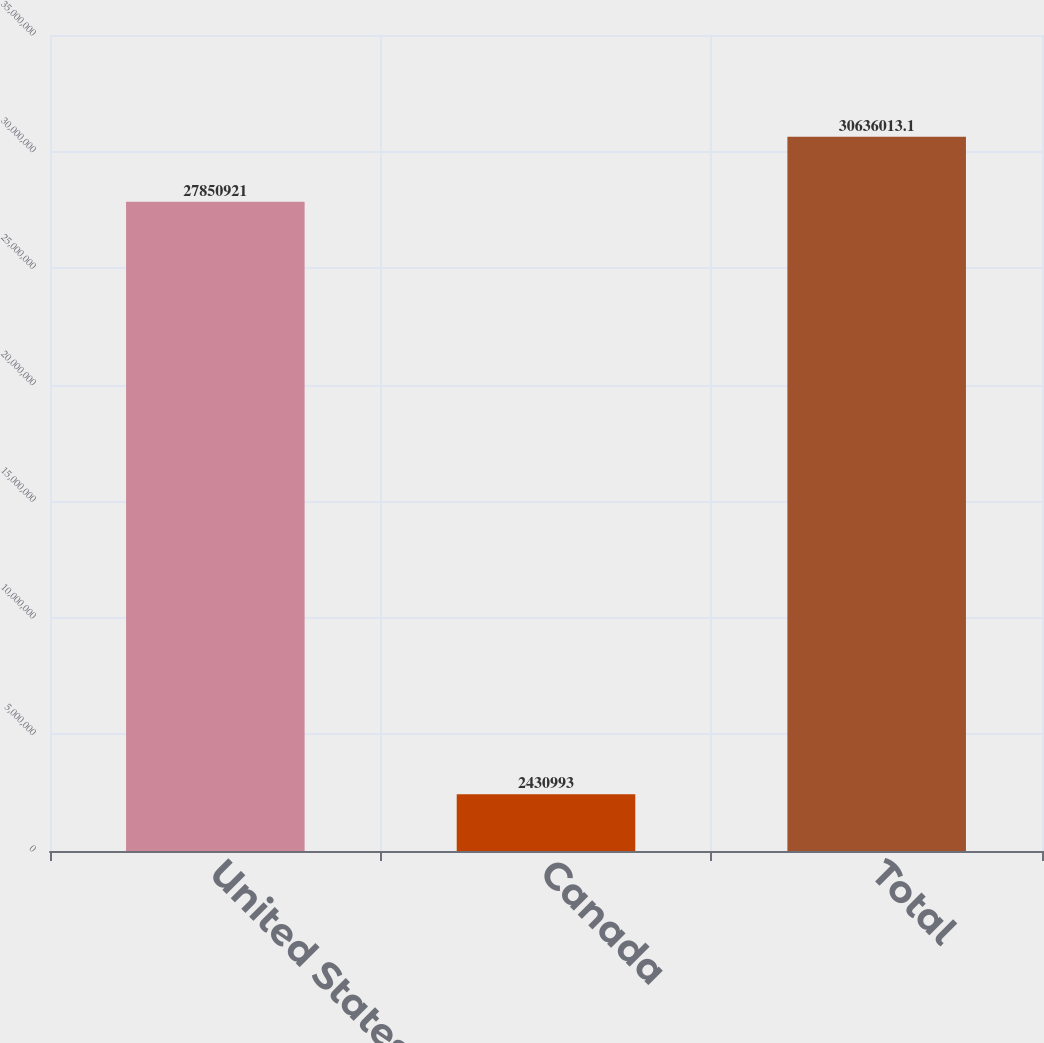Convert chart. <chart><loc_0><loc_0><loc_500><loc_500><bar_chart><fcel>United States<fcel>Canada<fcel>Total<nl><fcel>2.78509e+07<fcel>2.43099e+06<fcel>3.0636e+07<nl></chart> 